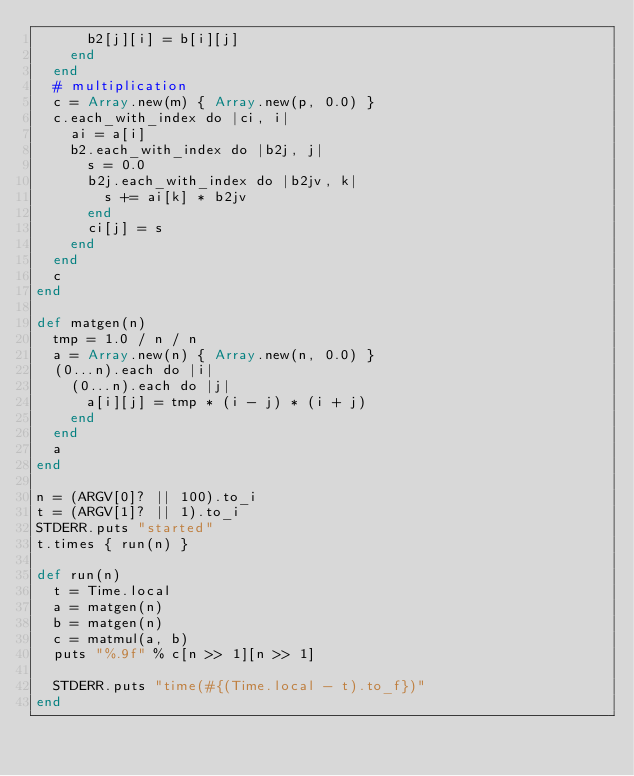Convert code to text. <code><loc_0><loc_0><loc_500><loc_500><_Crystal_>      b2[j][i] = b[i][j]
    end
  end
  # multiplication
  c = Array.new(m) { Array.new(p, 0.0) }
  c.each_with_index do |ci, i|
    ai = a[i]
    b2.each_with_index do |b2j, j|
      s = 0.0
      b2j.each_with_index do |b2jv, k|
        s += ai[k] * b2jv
      end
      ci[j] = s
    end
  end
  c
end

def matgen(n)
  tmp = 1.0 / n / n
  a = Array.new(n) { Array.new(n, 0.0) }
  (0...n).each do |i|
    (0...n).each do |j|
      a[i][j] = tmp * (i - j) * (i + j)
    end
  end
  a
end

n = (ARGV[0]? || 100).to_i
t = (ARGV[1]? || 1).to_i
STDERR.puts "started"
t.times { run(n) }

def run(n)
  t = Time.local
  a = matgen(n)
  b = matgen(n)
  c = matmul(a, b)
  puts "%.9f" % c[n >> 1][n >> 1]

  STDERR.puts "time(#{(Time.local - t).to_f})"
end
</code> 